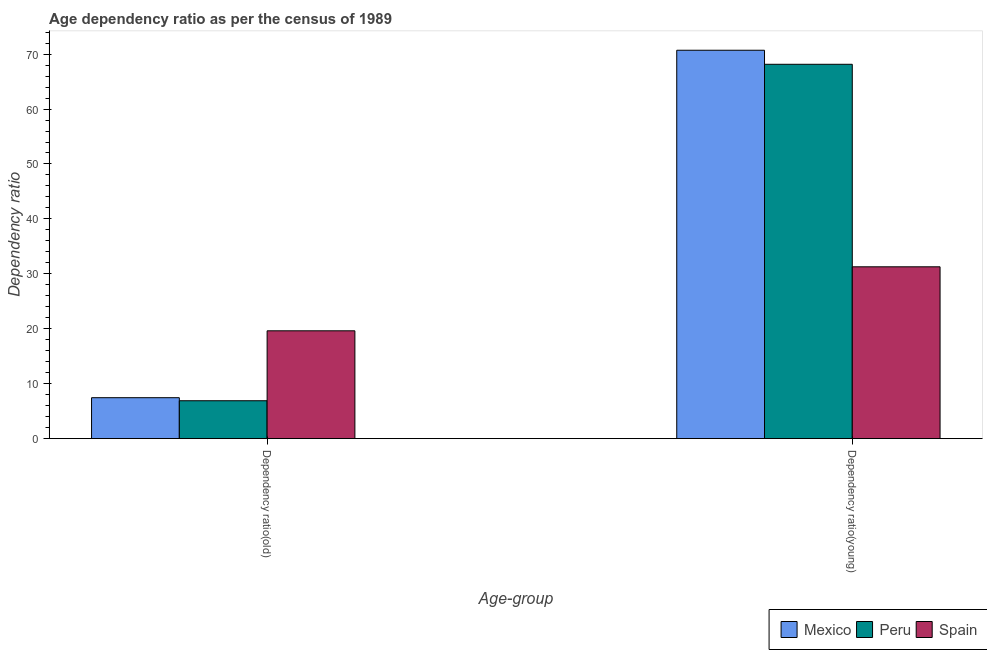How many different coloured bars are there?
Your response must be concise. 3. How many groups of bars are there?
Make the answer very short. 2. Are the number of bars per tick equal to the number of legend labels?
Offer a terse response. Yes. Are the number of bars on each tick of the X-axis equal?
Offer a terse response. Yes. How many bars are there on the 2nd tick from the right?
Your answer should be very brief. 3. What is the label of the 1st group of bars from the left?
Provide a short and direct response. Dependency ratio(old). What is the age dependency ratio(young) in Peru?
Give a very brief answer. 68.15. Across all countries, what is the maximum age dependency ratio(young)?
Make the answer very short. 70.71. Across all countries, what is the minimum age dependency ratio(young)?
Your answer should be compact. 31.28. What is the total age dependency ratio(young) in the graph?
Keep it short and to the point. 170.13. What is the difference between the age dependency ratio(old) in Spain and that in Mexico?
Offer a very short reply. 12.18. What is the difference between the age dependency ratio(young) in Peru and the age dependency ratio(old) in Spain?
Offer a terse response. 48.52. What is the average age dependency ratio(old) per country?
Offer a terse response. 11.32. What is the difference between the age dependency ratio(old) and age dependency ratio(young) in Spain?
Make the answer very short. -11.65. In how many countries, is the age dependency ratio(old) greater than 66 ?
Provide a short and direct response. 0. What is the ratio of the age dependency ratio(young) in Mexico to that in Peru?
Ensure brevity in your answer.  1.04. In how many countries, is the age dependency ratio(young) greater than the average age dependency ratio(young) taken over all countries?
Provide a succinct answer. 2. How many bars are there?
Keep it short and to the point. 6. Are all the bars in the graph horizontal?
Provide a succinct answer. No. What is the difference between two consecutive major ticks on the Y-axis?
Offer a very short reply. 10. Does the graph contain any zero values?
Keep it short and to the point. No. Where does the legend appear in the graph?
Your answer should be compact. Bottom right. How many legend labels are there?
Make the answer very short. 3. What is the title of the graph?
Your response must be concise. Age dependency ratio as per the census of 1989. What is the label or title of the X-axis?
Keep it short and to the point. Age-group. What is the label or title of the Y-axis?
Offer a terse response. Dependency ratio. What is the Dependency ratio of Mexico in Dependency ratio(old)?
Offer a very short reply. 7.45. What is the Dependency ratio in Peru in Dependency ratio(old)?
Offer a terse response. 6.9. What is the Dependency ratio of Spain in Dependency ratio(old)?
Your response must be concise. 19.63. What is the Dependency ratio of Mexico in Dependency ratio(young)?
Your answer should be compact. 70.71. What is the Dependency ratio of Peru in Dependency ratio(young)?
Ensure brevity in your answer.  68.15. What is the Dependency ratio in Spain in Dependency ratio(young)?
Your answer should be very brief. 31.28. Across all Age-group, what is the maximum Dependency ratio of Mexico?
Keep it short and to the point. 70.71. Across all Age-group, what is the maximum Dependency ratio of Peru?
Make the answer very short. 68.15. Across all Age-group, what is the maximum Dependency ratio in Spain?
Your answer should be very brief. 31.28. Across all Age-group, what is the minimum Dependency ratio in Mexico?
Your answer should be compact. 7.45. Across all Age-group, what is the minimum Dependency ratio in Peru?
Offer a very short reply. 6.9. Across all Age-group, what is the minimum Dependency ratio of Spain?
Offer a very short reply. 19.63. What is the total Dependency ratio of Mexico in the graph?
Your response must be concise. 78.16. What is the total Dependency ratio of Peru in the graph?
Make the answer very short. 75.05. What is the total Dependency ratio in Spain in the graph?
Provide a short and direct response. 50.91. What is the difference between the Dependency ratio of Mexico in Dependency ratio(old) and that in Dependency ratio(young)?
Offer a very short reply. -63.26. What is the difference between the Dependency ratio in Peru in Dependency ratio(old) and that in Dependency ratio(young)?
Your answer should be compact. -61.25. What is the difference between the Dependency ratio of Spain in Dependency ratio(old) and that in Dependency ratio(young)?
Give a very brief answer. -11.65. What is the difference between the Dependency ratio in Mexico in Dependency ratio(old) and the Dependency ratio in Peru in Dependency ratio(young)?
Ensure brevity in your answer.  -60.7. What is the difference between the Dependency ratio of Mexico in Dependency ratio(old) and the Dependency ratio of Spain in Dependency ratio(young)?
Offer a very short reply. -23.83. What is the difference between the Dependency ratio in Peru in Dependency ratio(old) and the Dependency ratio in Spain in Dependency ratio(young)?
Keep it short and to the point. -24.38. What is the average Dependency ratio of Mexico per Age-group?
Your answer should be very brief. 39.08. What is the average Dependency ratio in Peru per Age-group?
Keep it short and to the point. 37.52. What is the average Dependency ratio in Spain per Age-group?
Offer a terse response. 25.45. What is the difference between the Dependency ratio in Mexico and Dependency ratio in Peru in Dependency ratio(old)?
Offer a very short reply. 0.55. What is the difference between the Dependency ratio in Mexico and Dependency ratio in Spain in Dependency ratio(old)?
Provide a short and direct response. -12.18. What is the difference between the Dependency ratio of Peru and Dependency ratio of Spain in Dependency ratio(old)?
Provide a succinct answer. -12.73. What is the difference between the Dependency ratio in Mexico and Dependency ratio in Peru in Dependency ratio(young)?
Give a very brief answer. 2.56. What is the difference between the Dependency ratio in Mexico and Dependency ratio in Spain in Dependency ratio(young)?
Your answer should be compact. 39.43. What is the difference between the Dependency ratio in Peru and Dependency ratio in Spain in Dependency ratio(young)?
Offer a very short reply. 36.87. What is the ratio of the Dependency ratio of Mexico in Dependency ratio(old) to that in Dependency ratio(young)?
Your answer should be compact. 0.11. What is the ratio of the Dependency ratio of Peru in Dependency ratio(old) to that in Dependency ratio(young)?
Offer a very short reply. 0.1. What is the ratio of the Dependency ratio of Spain in Dependency ratio(old) to that in Dependency ratio(young)?
Keep it short and to the point. 0.63. What is the difference between the highest and the second highest Dependency ratio in Mexico?
Offer a terse response. 63.26. What is the difference between the highest and the second highest Dependency ratio of Peru?
Provide a succinct answer. 61.25. What is the difference between the highest and the second highest Dependency ratio in Spain?
Your response must be concise. 11.65. What is the difference between the highest and the lowest Dependency ratio in Mexico?
Keep it short and to the point. 63.26. What is the difference between the highest and the lowest Dependency ratio of Peru?
Keep it short and to the point. 61.25. What is the difference between the highest and the lowest Dependency ratio in Spain?
Give a very brief answer. 11.65. 